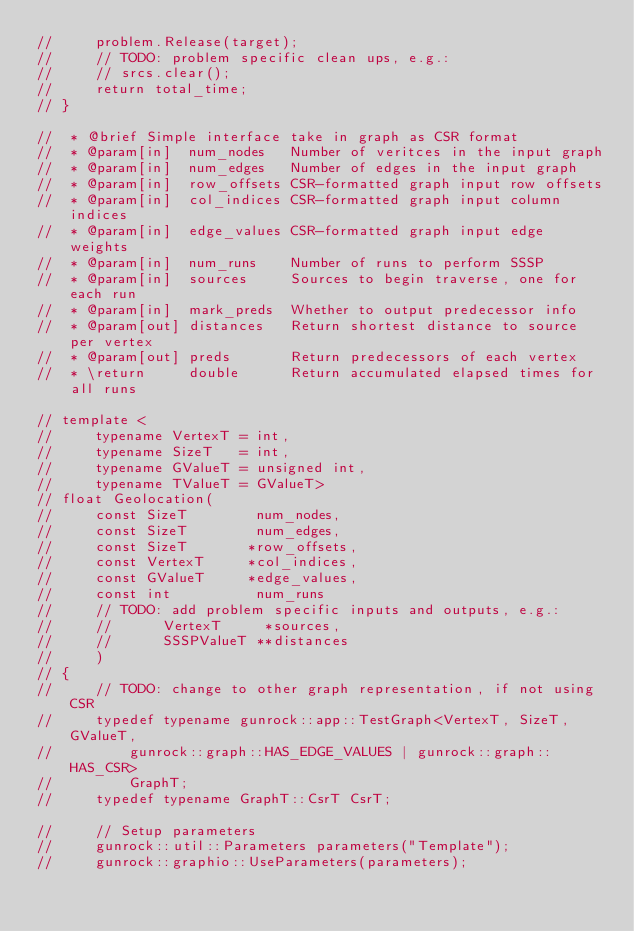<code> <loc_0><loc_0><loc_500><loc_500><_Cuda_>//     problem.Release(target);
//     // TODO: problem specific clean ups, e.g.:
//     // srcs.clear();
//     return total_time;
// }

//  * @brief Simple interface take in graph as CSR format
//  * @param[in]  num_nodes   Number of veritces in the input graph
//  * @param[in]  num_edges   Number of edges in the input graph
//  * @param[in]  row_offsets CSR-formatted graph input row offsets
//  * @param[in]  col_indices CSR-formatted graph input column indices
//  * @param[in]  edge_values CSR-formatted graph input edge weights
//  * @param[in]  num_runs    Number of runs to perform SSSP
//  * @param[in]  sources     Sources to begin traverse, one for each run
//  * @param[in]  mark_preds  Whether to output predecessor info
//  * @param[out] distances   Return shortest distance to source per vertex
//  * @param[out] preds       Return predecessors of each vertex
//  * \return     double      Return accumulated elapsed times for all runs

// template <
//     typename VertexT = int,
//     typename SizeT   = int,
//     typename GValueT = unsigned int,
//     typename TValueT = GValueT>
// float Geolocation(
//     const SizeT        num_nodes,
//     const SizeT        num_edges,
//     const SizeT       *row_offsets,
//     const VertexT     *col_indices,
//     const GValueT     *edge_values,
//     const int          num_runs
//     // TODO: add problem specific inputs and outputs, e.g.:
//     //      VertexT     *sources,
//     //      SSSPValueT **distances
//     )
// {
//     // TODO: change to other graph representation, if not using CSR
//     typedef typename gunrock::app::TestGraph<VertexT, SizeT, GValueT,
//         gunrock::graph::HAS_EDGE_VALUES | gunrock::graph::HAS_CSR>
//         GraphT;
//     typedef typename GraphT::CsrT CsrT;

//     // Setup parameters
//     gunrock::util::Parameters parameters("Template");
//     gunrock::graphio::UseParameters(parameters);</code> 